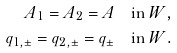Convert formula to latex. <formula><loc_0><loc_0><loc_500><loc_500>A _ { 1 } = A _ { 2 } = A & \quad \text {in } W , \\ q _ { 1 , \pm } = q _ { 2 , \pm } = q _ { \pm } & \quad \text {in } W .</formula> 